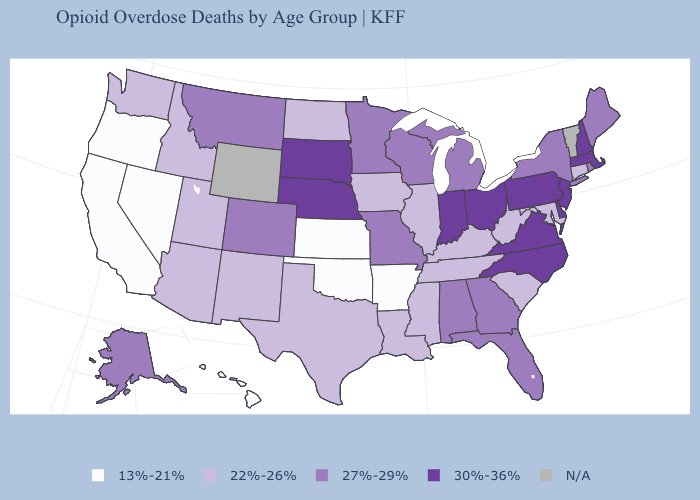What is the value of California?
Be succinct. 13%-21%. Does the first symbol in the legend represent the smallest category?
Give a very brief answer. Yes. What is the highest value in the West ?
Short answer required. 27%-29%. Does the first symbol in the legend represent the smallest category?
Be succinct. Yes. What is the value of Arkansas?
Write a very short answer. 13%-21%. Does the map have missing data?
Short answer required. Yes. Does the map have missing data?
Keep it brief. Yes. What is the value of Tennessee?
Keep it brief. 22%-26%. Among the states that border Missouri , does Illinois have the highest value?
Keep it brief. No. Which states hav the highest value in the Northeast?
Keep it brief. Massachusetts, New Hampshire, New Jersey, Pennsylvania. Name the states that have a value in the range 27%-29%?
Quick response, please. Alabama, Alaska, Colorado, Florida, Georgia, Maine, Michigan, Minnesota, Missouri, Montana, New York, Rhode Island, Wisconsin. What is the value of Rhode Island?
Concise answer only. 27%-29%. Does Hawaii have the lowest value in the USA?
Be succinct. Yes. Which states have the lowest value in the Northeast?
Keep it brief. Connecticut. What is the value of Pennsylvania?
Short answer required. 30%-36%. 